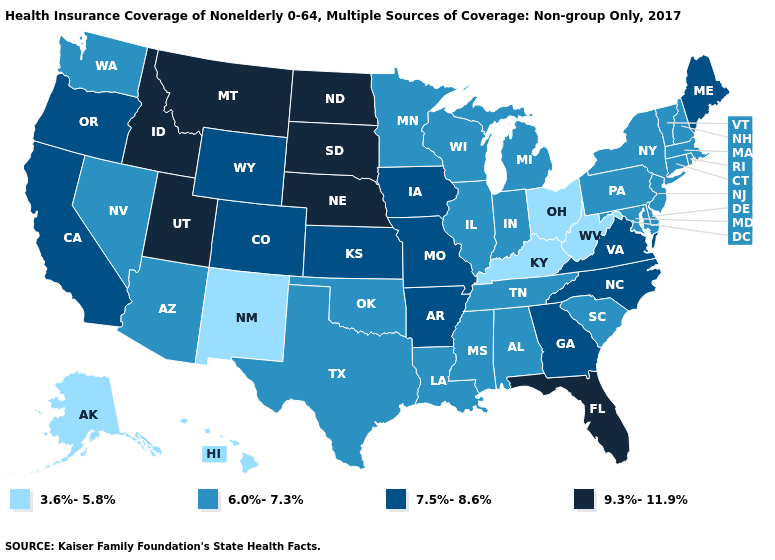Among the states that border Oregon , which have the lowest value?
Be succinct. Nevada, Washington. Does the first symbol in the legend represent the smallest category?
Write a very short answer. Yes. How many symbols are there in the legend?
Be succinct. 4. Does Iowa have the highest value in the USA?
Be succinct. No. What is the lowest value in the MidWest?
Give a very brief answer. 3.6%-5.8%. Which states have the lowest value in the USA?
Short answer required. Alaska, Hawaii, Kentucky, New Mexico, Ohio, West Virginia. Does the map have missing data?
Give a very brief answer. No. Name the states that have a value in the range 9.3%-11.9%?
Short answer required. Florida, Idaho, Montana, Nebraska, North Dakota, South Dakota, Utah. Name the states that have a value in the range 6.0%-7.3%?
Give a very brief answer. Alabama, Arizona, Connecticut, Delaware, Illinois, Indiana, Louisiana, Maryland, Massachusetts, Michigan, Minnesota, Mississippi, Nevada, New Hampshire, New Jersey, New York, Oklahoma, Pennsylvania, Rhode Island, South Carolina, Tennessee, Texas, Vermont, Washington, Wisconsin. What is the lowest value in the West?
Concise answer only. 3.6%-5.8%. Name the states that have a value in the range 6.0%-7.3%?
Concise answer only. Alabama, Arizona, Connecticut, Delaware, Illinois, Indiana, Louisiana, Maryland, Massachusetts, Michigan, Minnesota, Mississippi, Nevada, New Hampshire, New Jersey, New York, Oklahoma, Pennsylvania, Rhode Island, South Carolina, Tennessee, Texas, Vermont, Washington, Wisconsin. What is the highest value in the South ?
Answer briefly. 9.3%-11.9%. What is the value of Oklahoma?
Concise answer only. 6.0%-7.3%. Name the states that have a value in the range 3.6%-5.8%?
Keep it brief. Alaska, Hawaii, Kentucky, New Mexico, Ohio, West Virginia. 